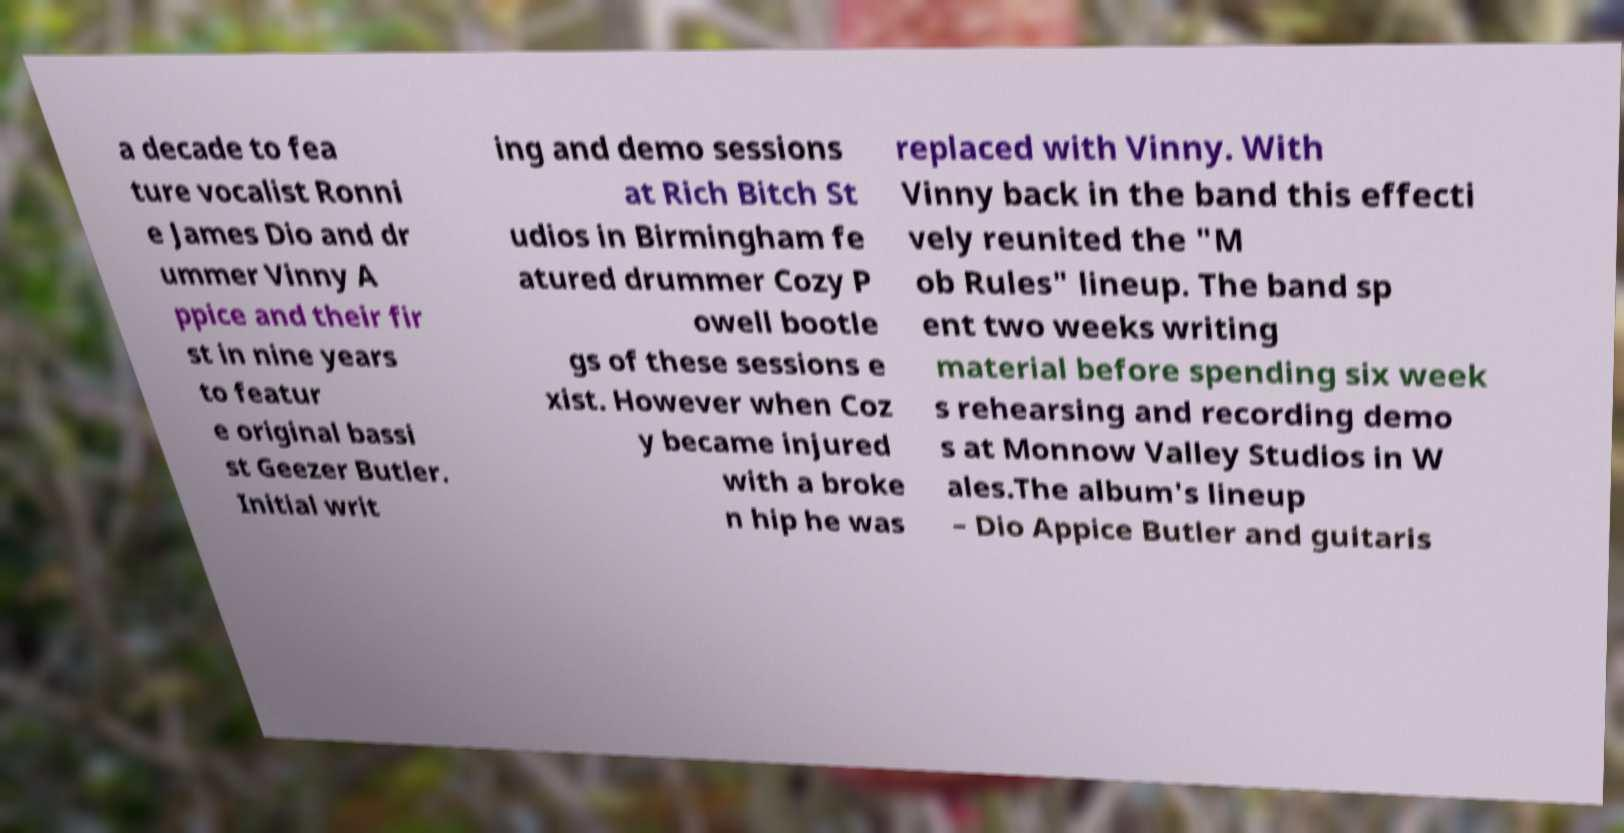For documentation purposes, I need the text within this image transcribed. Could you provide that? a decade to fea ture vocalist Ronni e James Dio and dr ummer Vinny A ppice and their fir st in nine years to featur e original bassi st Geezer Butler. Initial writ ing and demo sessions at Rich Bitch St udios in Birmingham fe atured drummer Cozy P owell bootle gs of these sessions e xist. However when Coz y became injured with a broke n hip he was replaced with Vinny. With Vinny back in the band this effecti vely reunited the "M ob Rules" lineup. The band sp ent two weeks writing material before spending six week s rehearsing and recording demo s at Monnow Valley Studios in W ales.The album's lineup – Dio Appice Butler and guitaris 